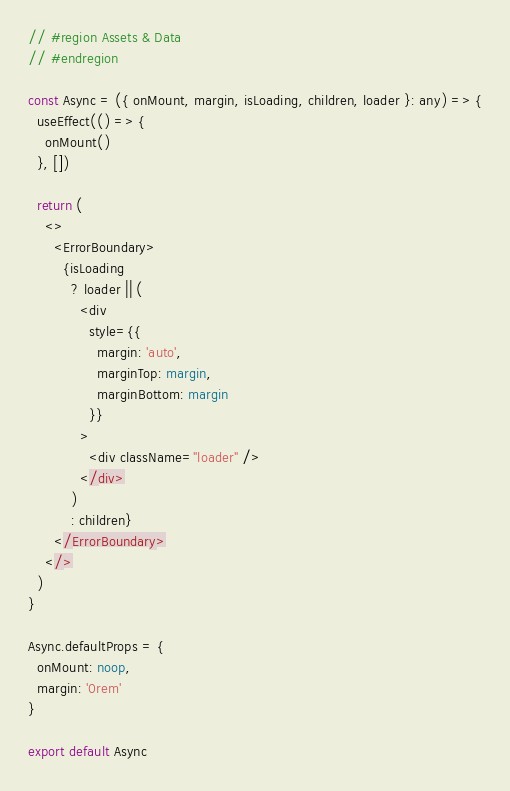<code> <loc_0><loc_0><loc_500><loc_500><_TypeScript_>
// #region Assets & Data
// #endregion

const Async = ({ onMount, margin, isLoading, children, loader }: any) => {
  useEffect(() => {
    onMount()
  }, [])

  return (
    <>
      <ErrorBoundary>
        {isLoading
          ? loader || (
            <div
              style={{
                margin: 'auto',
                marginTop: margin,
                marginBottom: margin
              }}
            >
              <div className="loader" />
            </div>
          )
          : children}
      </ErrorBoundary>
    </>
  )
}

Async.defaultProps = {
  onMount: noop,
  margin: '0rem'
}

export default Async
</code> 